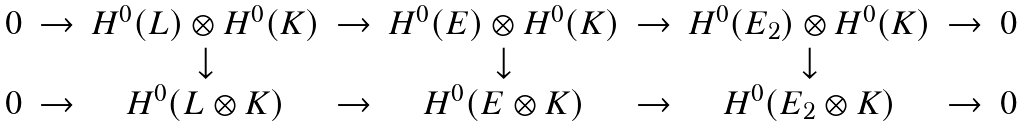Convert formula to latex. <formula><loc_0><loc_0><loc_500><loc_500>\begin{matrix} 0 & \rightarrow & H ^ { 0 } ( L ) \otimes H ^ { 0 } ( K ) & \rightarrow & H ^ { 0 } ( E ) \otimes H ^ { 0 } ( K ) & \rightarrow & H ^ { 0 } ( E _ { 2 } ) \otimes H ^ { 0 } ( K ) & \rightarrow & 0 \\ & & \downarrow & & \downarrow & & \downarrow & & \\ 0 & \rightarrow & H ^ { 0 } ( L \otimes K ) & \rightarrow & H ^ { 0 } ( E \otimes K ) & \rightarrow & H ^ { 0 } ( E _ { 2 } \otimes K ) & \rightarrow & 0 \\ \end{matrix}</formula> 